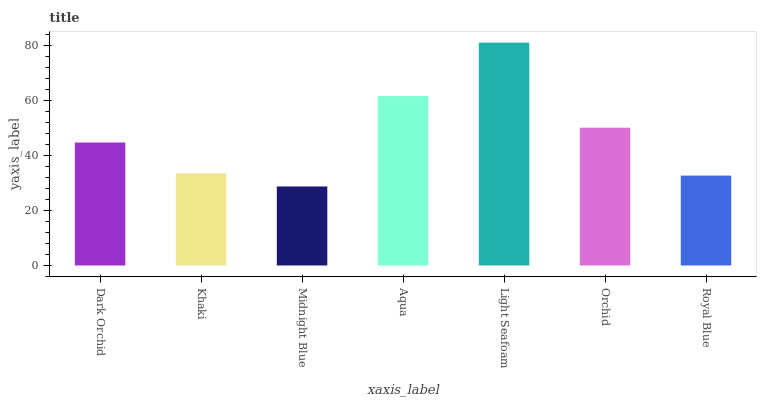Is Midnight Blue the minimum?
Answer yes or no. Yes. Is Light Seafoam the maximum?
Answer yes or no. Yes. Is Khaki the minimum?
Answer yes or no. No. Is Khaki the maximum?
Answer yes or no. No. Is Dark Orchid greater than Khaki?
Answer yes or no. Yes. Is Khaki less than Dark Orchid?
Answer yes or no. Yes. Is Khaki greater than Dark Orchid?
Answer yes or no. No. Is Dark Orchid less than Khaki?
Answer yes or no. No. Is Dark Orchid the high median?
Answer yes or no. Yes. Is Dark Orchid the low median?
Answer yes or no. Yes. Is Orchid the high median?
Answer yes or no. No. Is Midnight Blue the low median?
Answer yes or no. No. 